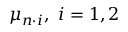Convert formula to latex. <formula><loc_0><loc_0><loc_500><loc_500>\mu _ { n \cdot i } , i = 1 , 2</formula> 